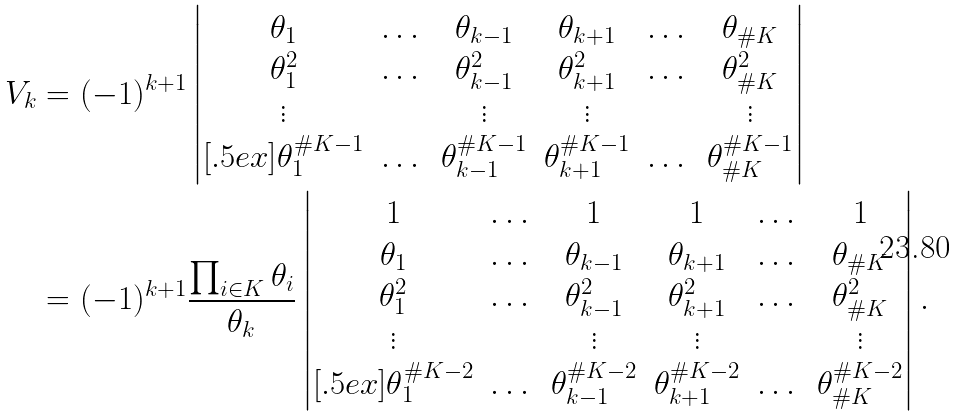Convert formula to latex. <formula><loc_0><loc_0><loc_500><loc_500>V _ { k } & = ( - 1 ) ^ { k + 1 } \begin{vmatrix} \theta _ { 1 } & \dots & \theta _ { k - 1 } & \theta _ { k + 1 } & \dots & \theta _ { \# K } \\ \theta _ { 1 } ^ { 2 } & \dots & \theta _ { k - 1 } ^ { 2 } & \theta _ { k + 1 } ^ { 2 } & \dots & \theta _ { \# K } ^ { 2 } \\ \vdots & & \vdots & \vdots & & \vdots \\ [ . 5 e x ] \theta _ { 1 } ^ { \# K - 1 } & \dots & \theta _ { k - 1 } ^ { \# K - 1 } & \theta _ { k + 1 } ^ { \# K - 1 } & \dots & \theta _ { \# K } ^ { \# K - 1 } \end{vmatrix} \\ & = ( - 1 ) ^ { k + 1 } \frac { \prod _ { i \in K } \theta _ { i } } { \theta _ { k } } \begin{vmatrix} 1 & \dots & 1 & 1 & \dots & 1 \\ \theta _ { 1 } & \dots & \theta _ { k - 1 } & \theta _ { k + 1 } & \dots & \theta _ { \# K } \\ \theta _ { 1 } ^ { 2 } & \dots & \theta _ { k - 1 } ^ { 2 } & \theta _ { k + 1 } ^ { 2 } & \dots & \theta _ { \# K } ^ { 2 } \\ \vdots & & \vdots & \vdots & & \vdots \\ [ . 5 e x ] \theta _ { 1 } ^ { \# K - 2 } & \dots & \theta _ { k - 1 } ^ { \# K - 2 } & \theta _ { k + 1 } ^ { \# K - 2 } & \dots & \theta _ { \# K } ^ { \# K - 2 } \end{vmatrix} .</formula> 